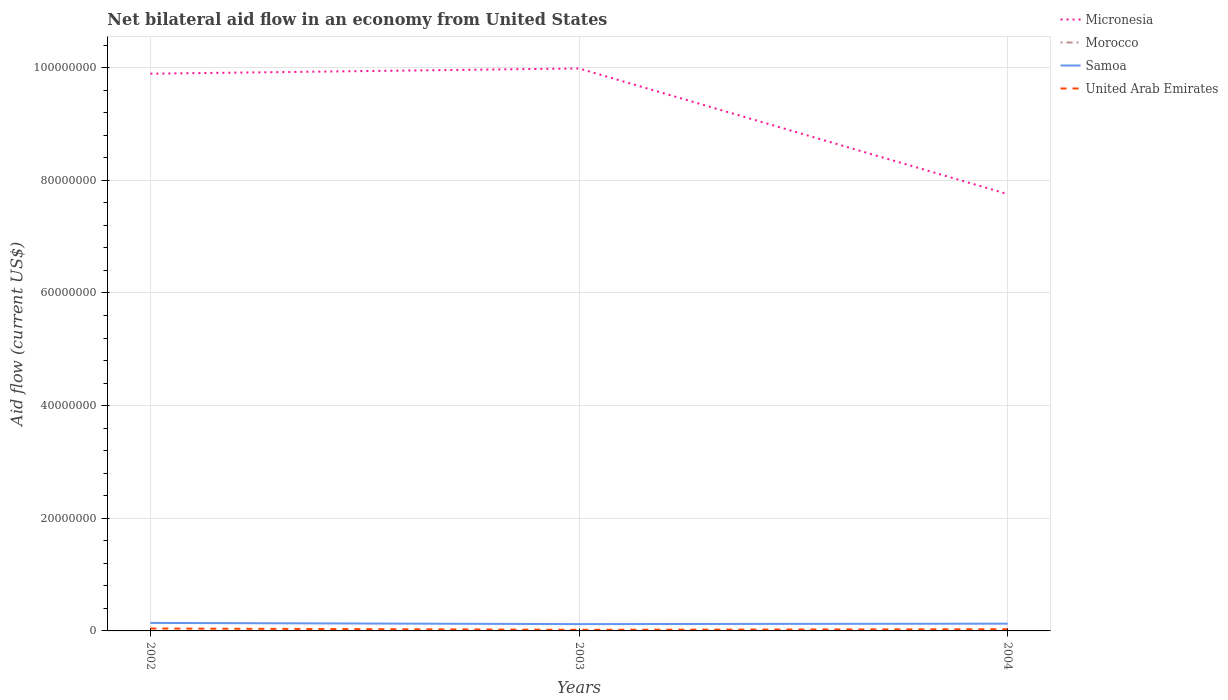Does the line corresponding to United Arab Emirates intersect with the line corresponding to Morocco?
Ensure brevity in your answer.  No. Across all years, what is the maximum net bilateral aid flow in Samoa?
Offer a terse response. 1.21e+06. What is the difference between the highest and the second highest net bilateral aid flow in Samoa?
Provide a succinct answer. 2.10e+05. What is the difference between the highest and the lowest net bilateral aid flow in Samoa?
Provide a succinct answer. 1. Is the net bilateral aid flow in Morocco strictly greater than the net bilateral aid flow in United Arab Emirates over the years?
Your answer should be very brief. Yes. How many years are there in the graph?
Offer a very short reply. 3. Does the graph contain any zero values?
Provide a short and direct response. Yes. Does the graph contain grids?
Offer a very short reply. Yes. Where does the legend appear in the graph?
Keep it short and to the point. Top right. How many legend labels are there?
Ensure brevity in your answer.  4. How are the legend labels stacked?
Your answer should be compact. Vertical. What is the title of the graph?
Your answer should be very brief. Net bilateral aid flow in an economy from United States. What is the label or title of the X-axis?
Your answer should be compact. Years. What is the label or title of the Y-axis?
Give a very brief answer. Aid flow (current US$). What is the Aid flow (current US$) of Micronesia in 2002?
Offer a terse response. 9.89e+07. What is the Aid flow (current US$) of Morocco in 2002?
Keep it short and to the point. 0. What is the Aid flow (current US$) of Samoa in 2002?
Make the answer very short. 1.42e+06. What is the Aid flow (current US$) of Micronesia in 2003?
Provide a succinct answer. 9.99e+07. What is the Aid flow (current US$) of Morocco in 2003?
Give a very brief answer. 0. What is the Aid flow (current US$) in Samoa in 2003?
Provide a short and direct response. 1.21e+06. What is the Aid flow (current US$) in Micronesia in 2004?
Your answer should be very brief. 7.76e+07. What is the Aid flow (current US$) in Samoa in 2004?
Give a very brief answer. 1.29e+06. Across all years, what is the maximum Aid flow (current US$) in Micronesia?
Give a very brief answer. 9.99e+07. Across all years, what is the maximum Aid flow (current US$) in Samoa?
Provide a succinct answer. 1.42e+06. Across all years, what is the maximum Aid flow (current US$) in United Arab Emirates?
Make the answer very short. 4.30e+05. Across all years, what is the minimum Aid flow (current US$) of Micronesia?
Keep it short and to the point. 7.76e+07. Across all years, what is the minimum Aid flow (current US$) of Samoa?
Keep it short and to the point. 1.21e+06. Across all years, what is the minimum Aid flow (current US$) in United Arab Emirates?
Give a very brief answer. 2.00e+05. What is the total Aid flow (current US$) of Micronesia in the graph?
Provide a succinct answer. 2.76e+08. What is the total Aid flow (current US$) in Samoa in the graph?
Offer a very short reply. 3.92e+06. What is the total Aid flow (current US$) in United Arab Emirates in the graph?
Your response must be concise. 9.30e+05. What is the difference between the Aid flow (current US$) of Micronesia in 2002 and that in 2003?
Offer a terse response. -9.30e+05. What is the difference between the Aid flow (current US$) of Samoa in 2002 and that in 2003?
Provide a short and direct response. 2.10e+05. What is the difference between the Aid flow (current US$) in United Arab Emirates in 2002 and that in 2003?
Offer a terse response. 2.30e+05. What is the difference between the Aid flow (current US$) of Micronesia in 2002 and that in 2004?
Give a very brief answer. 2.14e+07. What is the difference between the Aid flow (current US$) in Samoa in 2002 and that in 2004?
Give a very brief answer. 1.30e+05. What is the difference between the Aid flow (current US$) in United Arab Emirates in 2002 and that in 2004?
Provide a succinct answer. 1.30e+05. What is the difference between the Aid flow (current US$) of Micronesia in 2003 and that in 2004?
Offer a very short reply. 2.23e+07. What is the difference between the Aid flow (current US$) in Micronesia in 2002 and the Aid flow (current US$) in Samoa in 2003?
Offer a very short reply. 9.77e+07. What is the difference between the Aid flow (current US$) in Micronesia in 2002 and the Aid flow (current US$) in United Arab Emirates in 2003?
Offer a terse response. 9.87e+07. What is the difference between the Aid flow (current US$) in Samoa in 2002 and the Aid flow (current US$) in United Arab Emirates in 2003?
Your response must be concise. 1.22e+06. What is the difference between the Aid flow (current US$) of Micronesia in 2002 and the Aid flow (current US$) of Samoa in 2004?
Keep it short and to the point. 9.76e+07. What is the difference between the Aid flow (current US$) of Micronesia in 2002 and the Aid flow (current US$) of United Arab Emirates in 2004?
Ensure brevity in your answer.  9.86e+07. What is the difference between the Aid flow (current US$) in Samoa in 2002 and the Aid flow (current US$) in United Arab Emirates in 2004?
Offer a terse response. 1.12e+06. What is the difference between the Aid flow (current US$) in Micronesia in 2003 and the Aid flow (current US$) in Samoa in 2004?
Keep it short and to the point. 9.86e+07. What is the difference between the Aid flow (current US$) in Micronesia in 2003 and the Aid flow (current US$) in United Arab Emirates in 2004?
Make the answer very short. 9.96e+07. What is the difference between the Aid flow (current US$) of Samoa in 2003 and the Aid flow (current US$) of United Arab Emirates in 2004?
Make the answer very short. 9.10e+05. What is the average Aid flow (current US$) of Micronesia per year?
Offer a very short reply. 9.21e+07. What is the average Aid flow (current US$) in Samoa per year?
Your answer should be very brief. 1.31e+06. In the year 2002, what is the difference between the Aid flow (current US$) in Micronesia and Aid flow (current US$) in Samoa?
Your answer should be very brief. 9.75e+07. In the year 2002, what is the difference between the Aid flow (current US$) of Micronesia and Aid flow (current US$) of United Arab Emirates?
Offer a terse response. 9.85e+07. In the year 2002, what is the difference between the Aid flow (current US$) of Samoa and Aid flow (current US$) of United Arab Emirates?
Your response must be concise. 9.90e+05. In the year 2003, what is the difference between the Aid flow (current US$) in Micronesia and Aid flow (current US$) in Samoa?
Your answer should be compact. 9.86e+07. In the year 2003, what is the difference between the Aid flow (current US$) of Micronesia and Aid flow (current US$) of United Arab Emirates?
Keep it short and to the point. 9.97e+07. In the year 2003, what is the difference between the Aid flow (current US$) of Samoa and Aid flow (current US$) of United Arab Emirates?
Your answer should be very brief. 1.01e+06. In the year 2004, what is the difference between the Aid flow (current US$) of Micronesia and Aid flow (current US$) of Samoa?
Ensure brevity in your answer.  7.63e+07. In the year 2004, what is the difference between the Aid flow (current US$) in Micronesia and Aid flow (current US$) in United Arab Emirates?
Your answer should be compact. 7.72e+07. In the year 2004, what is the difference between the Aid flow (current US$) in Samoa and Aid flow (current US$) in United Arab Emirates?
Keep it short and to the point. 9.90e+05. What is the ratio of the Aid flow (current US$) of Micronesia in 2002 to that in 2003?
Your answer should be compact. 0.99. What is the ratio of the Aid flow (current US$) of Samoa in 2002 to that in 2003?
Offer a terse response. 1.17. What is the ratio of the Aid flow (current US$) of United Arab Emirates in 2002 to that in 2003?
Ensure brevity in your answer.  2.15. What is the ratio of the Aid flow (current US$) in Micronesia in 2002 to that in 2004?
Offer a very short reply. 1.28. What is the ratio of the Aid flow (current US$) in Samoa in 2002 to that in 2004?
Your answer should be very brief. 1.1. What is the ratio of the Aid flow (current US$) of United Arab Emirates in 2002 to that in 2004?
Provide a succinct answer. 1.43. What is the ratio of the Aid flow (current US$) in Micronesia in 2003 to that in 2004?
Your answer should be compact. 1.29. What is the ratio of the Aid flow (current US$) in Samoa in 2003 to that in 2004?
Ensure brevity in your answer.  0.94. What is the difference between the highest and the second highest Aid flow (current US$) of Micronesia?
Your response must be concise. 9.30e+05. What is the difference between the highest and the second highest Aid flow (current US$) in Samoa?
Your answer should be very brief. 1.30e+05. What is the difference between the highest and the lowest Aid flow (current US$) of Micronesia?
Ensure brevity in your answer.  2.23e+07. What is the difference between the highest and the lowest Aid flow (current US$) of Samoa?
Offer a terse response. 2.10e+05. What is the difference between the highest and the lowest Aid flow (current US$) in United Arab Emirates?
Give a very brief answer. 2.30e+05. 